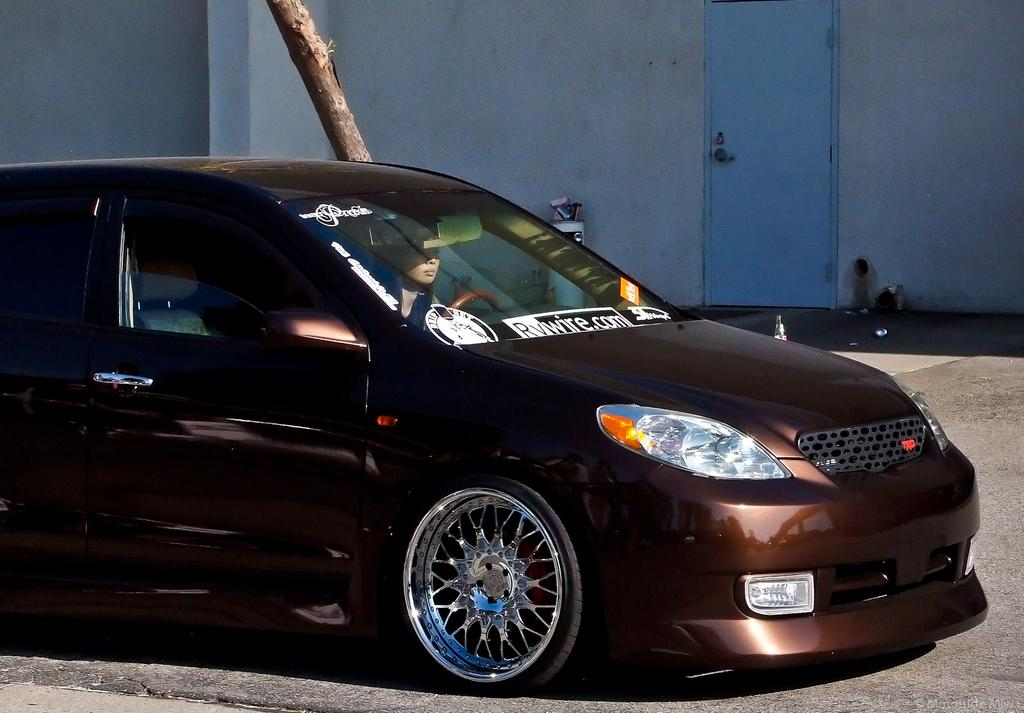What is the main subject in the center of the image? There is a car in the center of the image. Who is inside the car? A woman is sitting in the car. What can be seen in the background of the image? There is a wooden stick, a wall, and a door in the background of the image. What is at the bottom of the image? There is a road at the bottom of the image. What type of quilt is being used to cover the car in the image? There is no quilt present in the image; it features a car with a woman sitting inside. What is the cause of the quartz formation in the background of the image? There is no quartz formation present in the image; it features a wooden stick, a wall, and a door in the background. 